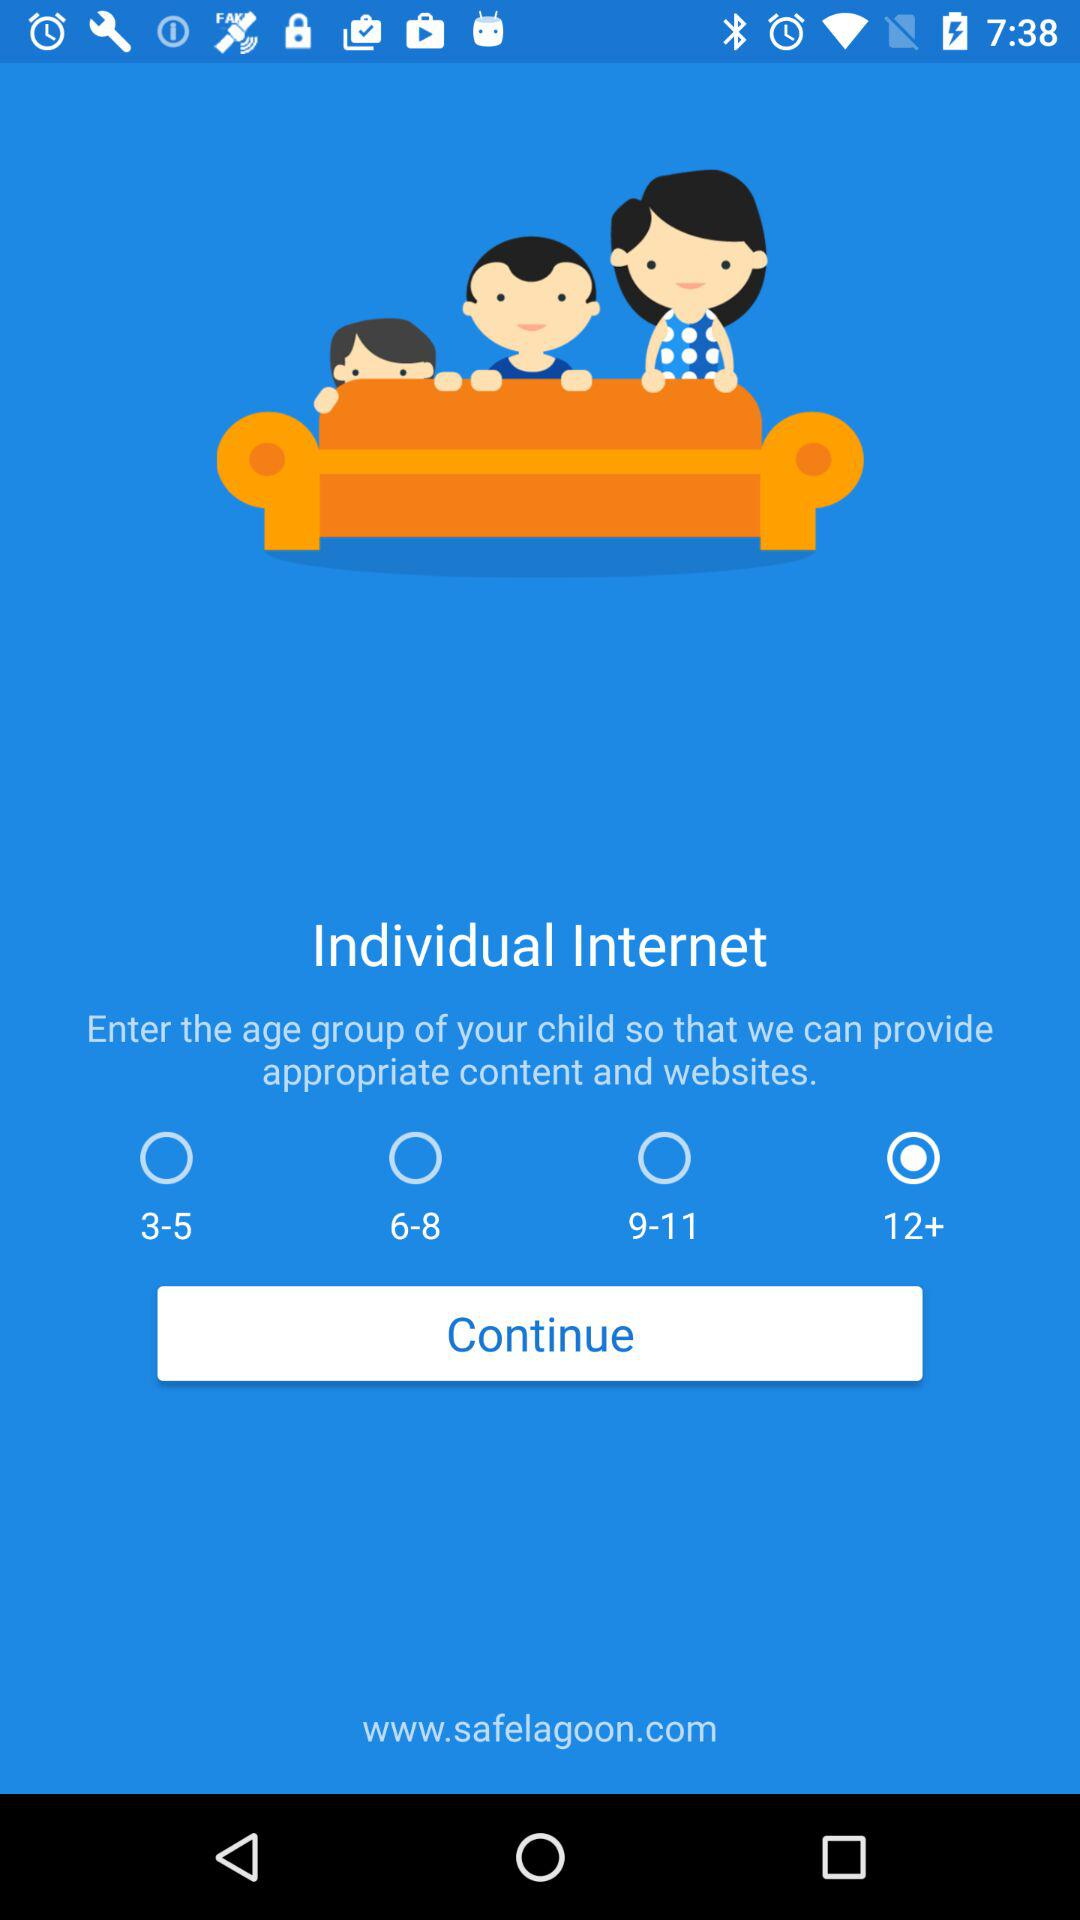How many age groups are there?
Answer the question using a single word or phrase. 4 